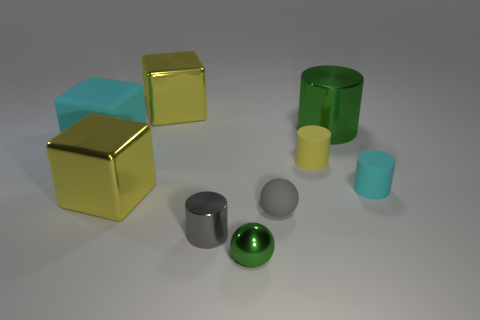Subtract 1 cylinders. How many cylinders are left? 3 Add 1 rubber balls. How many objects exist? 10 Subtract all balls. How many objects are left? 7 Add 8 big rubber objects. How many big rubber objects are left? 9 Add 6 gray rubber balls. How many gray rubber balls exist? 7 Subtract 0 gray cubes. How many objects are left? 9 Subtract all yellow spheres. Subtract all yellow rubber objects. How many objects are left? 8 